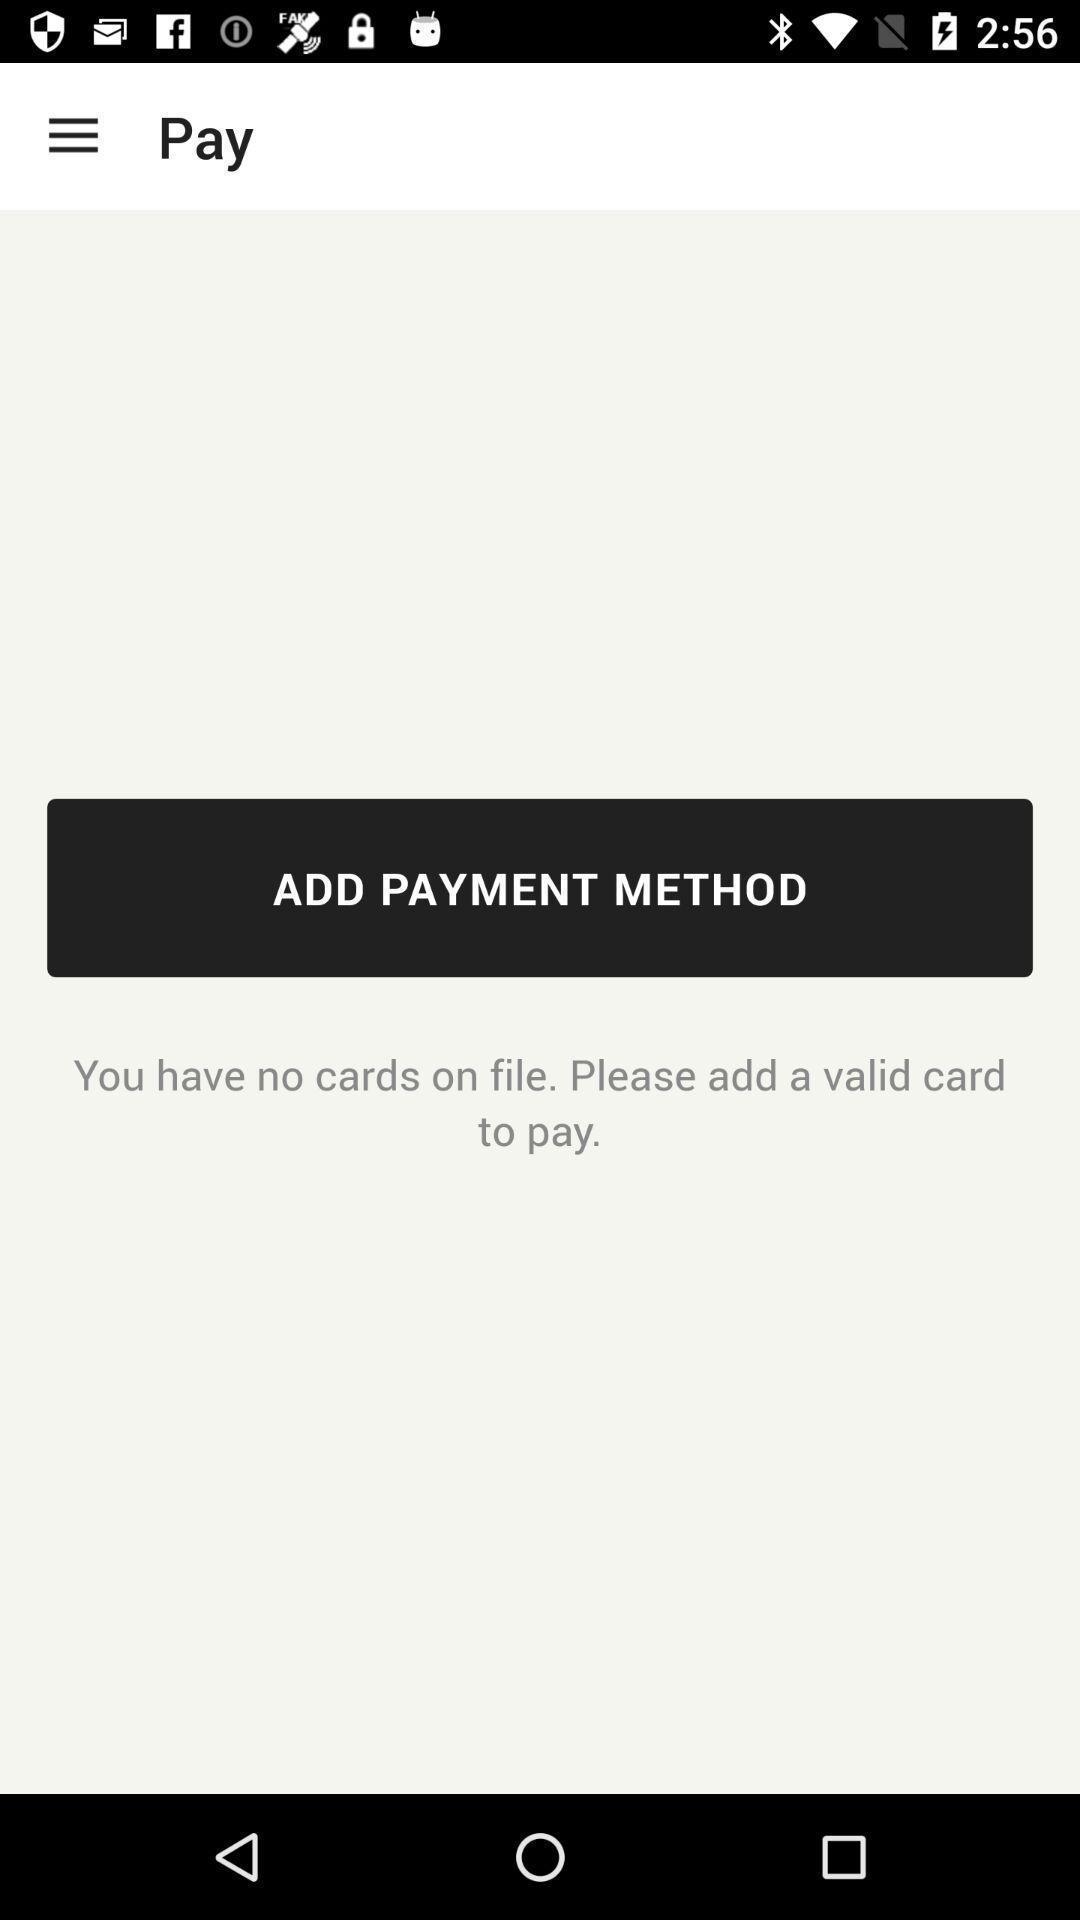Provide a textual representation of this image. Screen displaying the payment methods page. 